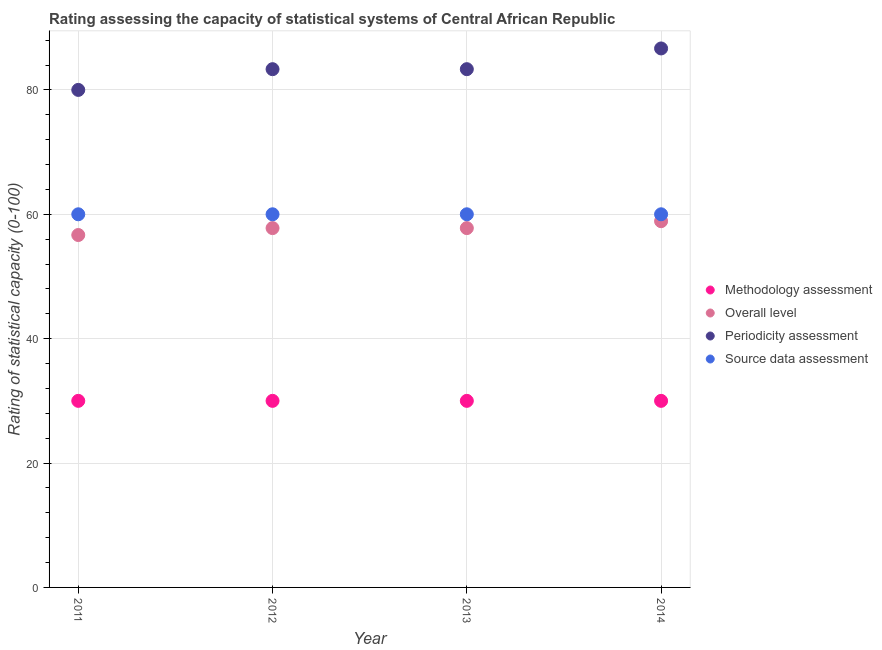How many different coloured dotlines are there?
Give a very brief answer. 4. Is the number of dotlines equal to the number of legend labels?
Your answer should be very brief. Yes. What is the periodicity assessment rating in 2011?
Ensure brevity in your answer.  80. Across all years, what is the maximum periodicity assessment rating?
Ensure brevity in your answer.  86.67. Across all years, what is the minimum methodology assessment rating?
Keep it short and to the point. 30. In which year was the methodology assessment rating maximum?
Offer a very short reply. 2011. In which year was the overall level rating minimum?
Make the answer very short. 2011. What is the total methodology assessment rating in the graph?
Offer a terse response. 120. What is the difference between the periodicity assessment rating in 2011 and that in 2013?
Offer a terse response. -3.33. What is the difference between the source data assessment rating in 2011 and the periodicity assessment rating in 2014?
Give a very brief answer. -26.67. In the year 2012, what is the difference between the overall level rating and periodicity assessment rating?
Provide a short and direct response. -25.56. What is the ratio of the source data assessment rating in 2013 to that in 2014?
Make the answer very short. 1. Is the source data assessment rating in 2011 less than that in 2013?
Your response must be concise. No. Is the difference between the periodicity assessment rating in 2011 and 2014 greater than the difference between the methodology assessment rating in 2011 and 2014?
Your response must be concise. No. What is the difference between the highest and the second highest methodology assessment rating?
Give a very brief answer. 0. In how many years, is the methodology assessment rating greater than the average methodology assessment rating taken over all years?
Offer a very short reply. 0. Is the sum of the periodicity assessment rating in 2013 and 2014 greater than the maximum source data assessment rating across all years?
Keep it short and to the point. Yes. Is the overall level rating strictly less than the methodology assessment rating over the years?
Your answer should be compact. No. What is the difference between two consecutive major ticks on the Y-axis?
Your answer should be compact. 20. Does the graph contain any zero values?
Offer a very short reply. No. Where does the legend appear in the graph?
Provide a short and direct response. Center right. How many legend labels are there?
Provide a succinct answer. 4. How are the legend labels stacked?
Your response must be concise. Vertical. What is the title of the graph?
Offer a terse response. Rating assessing the capacity of statistical systems of Central African Republic. Does "Taxes on exports" appear as one of the legend labels in the graph?
Keep it short and to the point. No. What is the label or title of the X-axis?
Your answer should be very brief. Year. What is the label or title of the Y-axis?
Offer a terse response. Rating of statistical capacity (0-100). What is the Rating of statistical capacity (0-100) in Overall level in 2011?
Keep it short and to the point. 56.67. What is the Rating of statistical capacity (0-100) in Overall level in 2012?
Your answer should be very brief. 57.78. What is the Rating of statistical capacity (0-100) of Periodicity assessment in 2012?
Your response must be concise. 83.33. What is the Rating of statistical capacity (0-100) of Source data assessment in 2012?
Provide a succinct answer. 60. What is the Rating of statistical capacity (0-100) of Overall level in 2013?
Your answer should be very brief. 57.78. What is the Rating of statistical capacity (0-100) in Periodicity assessment in 2013?
Keep it short and to the point. 83.33. What is the Rating of statistical capacity (0-100) of Source data assessment in 2013?
Give a very brief answer. 60. What is the Rating of statistical capacity (0-100) in Methodology assessment in 2014?
Keep it short and to the point. 30. What is the Rating of statistical capacity (0-100) in Overall level in 2014?
Your response must be concise. 58.89. What is the Rating of statistical capacity (0-100) of Periodicity assessment in 2014?
Offer a terse response. 86.67. What is the Rating of statistical capacity (0-100) of Source data assessment in 2014?
Give a very brief answer. 60. Across all years, what is the maximum Rating of statistical capacity (0-100) of Methodology assessment?
Give a very brief answer. 30. Across all years, what is the maximum Rating of statistical capacity (0-100) of Overall level?
Keep it short and to the point. 58.89. Across all years, what is the maximum Rating of statistical capacity (0-100) in Periodicity assessment?
Provide a succinct answer. 86.67. Across all years, what is the maximum Rating of statistical capacity (0-100) in Source data assessment?
Your answer should be compact. 60. Across all years, what is the minimum Rating of statistical capacity (0-100) of Methodology assessment?
Your answer should be compact. 30. Across all years, what is the minimum Rating of statistical capacity (0-100) of Overall level?
Your response must be concise. 56.67. Across all years, what is the minimum Rating of statistical capacity (0-100) in Periodicity assessment?
Your response must be concise. 80. Across all years, what is the minimum Rating of statistical capacity (0-100) of Source data assessment?
Ensure brevity in your answer.  60. What is the total Rating of statistical capacity (0-100) in Methodology assessment in the graph?
Offer a terse response. 120. What is the total Rating of statistical capacity (0-100) in Overall level in the graph?
Make the answer very short. 231.11. What is the total Rating of statistical capacity (0-100) of Periodicity assessment in the graph?
Your response must be concise. 333.33. What is the total Rating of statistical capacity (0-100) of Source data assessment in the graph?
Make the answer very short. 240. What is the difference between the Rating of statistical capacity (0-100) in Overall level in 2011 and that in 2012?
Ensure brevity in your answer.  -1.11. What is the difference between the Rating of statistical capacity (0-100) in Periodicity assessment in 2011 and that in 2012?
Provide a short and direct response. -3.33. What is the difference between the Rating of statistical capacity (0-100) in Overall level in 2011 and that in 2013?
Offer a very short reply. -1.11. What is the difference between the Rating of statistical capacity (0-100) of Source data assessment in 2011 and that in 2013?
Keep it short and to the point. 0. What is the difference between the Rating of statistical capacity (0-100) of Methodology assessment in 2011 and that in 2014?
Offer a terse response. 0. What is the difference between the Rating of statistical capacity (0-100) in Overall level in 2011 and that in 2014?
Make the answer very short. -2.22. What is the difference between the Rating of statistical capacity (0-100) of Periodicity assessment in 2011 and that in 2014?
Your answer should be compact. -6.67. What is the difference between the Rating of statistical capacity (0-100) in Source data assessment in 2011 and that in 2014?
Provide a short and direct response. 0. What is the difference between the Rating of statistical capacity (0-100) in Overall level in 2012 and that in 2013?
Make the answer very short. 0. What is the difference between the Rating of statistical capacity (0-100) in Source data assessment in 2012 and that in 2013?
Your answer should be very brief. 0. What is the difference between the Rating of statistical capacity (0-100) in Overall level in 2012 and that in 2014?
Offer a terse response. -1.11. What is the difference between the Rating of statistical capacity (0-100) in Periodicity assessment in 2012 and that in 2014?
Ensure brevity in your answer.  -3.33. What is the difference between the Rating of statistical capacity (0-100) in Overall level in 2013 and that in 2014?
Your answer should be compact. -1.11. What is the difference between the Rating of statistical capacity (0-100) in Periodicity assessment in 2013 and that in 2014?
Your answer should be very brief. -3.33. What is the difference between the Rating of statistical capacity (0-100) of Source data assessment in 2013 and that in 2014?
Offer a terse response. 0. What is the difference between the Rating of statistical capacity (0-100) in Methodology assessment in 2011 and the Rating of statistical capacity (0-100) in Overall level in 2012?
Your response must be concise. -27.78. What is the difference between the Rating of statistical capacity (0-100) of Methodology assessment in 2011 and the Rating of statistical capacity (0-100) of Periodicity assessment in 2012?
Your answer should be compact. -53.33. What is the difference between the Rating of statistical capacity (0-100) of Methodology assessment in 2011 and the Rating of statistical capacity (0-100) of Source data assessment in 2012?
Keep it short and to the point. -30. What is the difference between the Rating of statistical capacity (0-100) in Overall level in 2011 and the Rating of statistical capacity (0-100) in Periodicity assessment in 2012?
Provide a short and direct response. -26.67. What is the difference between the Rating of statistical capacity (0-100) in Overall level in 2011 and the Rating of statistical capacity (0-100) in Source data assessment in 2012?
Give a very brief answer. -3.33. What is the difference between the Rating of statistical capacity (0-100) of Methodology assessment in 2011 and the Rating of statistical capacity (0-100) of Overall level in 2013?
Your response must be concise. -27.78. What is the difference between the Rating of statistical capacity (0-100) of Methodology assessment in 2011 and the Rating of statistical capacity (0-100) of Periodicity assessment in 2013?
Your answer should be compact. -53.33. What is the difference between the Rating of statistical capacity (0-100) of Methodology assessment in 2011 and the Rating of statistical capacity (0-100) of Source data assessment in 2013?
Keep it short and to the point. -30. What is the difference between the Rating of statistical capacity (0-100) of Overall level in 2011 and the Rating of statistical capacity (0-100) of Periodicity assessment in 2013?
Your answer should be very brief. -26.67. What is the difference between the Rating of statistical capacity (0-100) in Overall level in 2011 and the Rating of statistical capacity (0-100) in Source data assessment in 2013?
Make the answer very short. -3.33. What is the difference between the Rating of statistical capacity (0-100) of Periodicity assessment in 2011 and the Rating of statistical capacity (0-100) of Source data assessment in 2013?
Provide a succinct answer. 20. What is the difference between the Rating of statistical capacity (0-100) of Methodology assessment in 2011 and the Rating of statistical capacity (0-100) of Overall level in 2014?
Ensure brevity in your answer.  -28.89. What is the difference between the Rating of statistical capacity (0-100) of Methodology assessment in 2011 and the Rating of statistical capacity (0-100) of Periodicity assessment in 2014?
Give a very brief answer. -56.67. What is the difference between the Rating of statistical capacity (0-100) in Methodology assessment in 2011 and the Rating of statistical capacity (0-100) in Source data assessment in 2014?
Your response must be concise. -30. What is the difference between the Rating of statistical capacity (0-100) in Overall level in 2011 and the Rating of statistical capacity (0-100) in Periodicity assessment in 2014?
Your response must be concise. -30. What is the difference between the Rating of statistical capacity (0-100) of Methodology assessment in 2012 and the Rating of statistical capacity (0-100) of Overall level in 2013?
Provide a succinct answer. -27.78. What is the difference between the Rating of statistical capacity (0-100) in Methodology assessment in 2012 and the Rating of statistical capacity (0-100) in Periodicity assessment in 2013?
Ensure brevity in your answer.  -53.33. What is the difference between the Rating of statistical capacity (0-100) in Overall level in 2012 and the Rating of statistical capacity (0-100) in Periodicity assessment in 2013?
Provide a succinct answer. -25.56. What is the difference between the Rating of statistical capacity (0-100) in Overall level in 2012 and the Rating of statistical capacity (0-100) in Source data assessment in 2013?
Your response must be concise. -2.22. What is the difference between the Rating of statistical capacity (0-100) of Periodicity assessment in 2012 and the Rating of statistical capacity (0-100) of Source data assessment in 2013?
Your answer should be compact. 23.33. What is the difference between the Rating of statistical capacity (0-100) in Methodology assessment in 2012 and the Rating of statistical capacity (0-100) in Overall level in 2014?
Your answer should be compact. -28.89. What is the difference between the Rating of statistical capacity (0-100) in Methodology assessment in 2012 and the Rating of statistical capacity (0-100) in Periodicity assessment in 2014?
Keep it short and to the point. -56.67. What is the difference between the Rating of statistical capacity (0-100) in Methodology assessment in 2012 and the Rating of statistical capacity (0-100) in Source data assessment in 2014?
Provide a short and direct response. -30. What is the difference between the Rating of statistical capacity (0-100) of Overall level in 2012 and the Rating of statistical capacity (0-100) of Periodicity assessment in 2014?
Provide a short and direct response. -28.89. What is the difference between the Rating of statistical capacity (0-100) in Overall level in 2012 and the Rating of statistical capacity (0-100) in Source data assessment in 2014?
Keep it short and to the point. -2.22. What is the difference between the Rating of statistical capacity (0-100) in Periodicity assessment in 2012 and the Rating of statistical capacity (0-100) in Source data assessment in 2014?
Keep it short and to the point. 23.33. What is the difference between the Rating of statistical capacity (0-100) in Methodology assessment in 2013 and the Rating of statistical capacity (0-100) in Overall level in 2014?
Your response must be concise. -28.89. What is the difference between the Rating of statistical capacity (0-100) in Methodology assessment in 2013 and the Rating of statistical capacity (0-100) in Periodicity assessment in 2014?
Offer a very short reply. -56.67. What is the difference between the Rating of statistical capacity (0-100) of Methodology assessment in 2013 and the Rating of statistical capacity (0-100) of Source data assessment in 2014?
Your answer should be compact. -30. What is the difference between the Rating of statistical capacity (0-100) of Overall level in 2013 and the Rating of statistical capacity (0-100) of Periodicity assessment in 2014?
Offer a very short reply. -28.89. What is the difference between the Rating of statistical capacity (0-100) in Overall level in 2013 and the Rating of statistical capacity (0-100) in Source data assessment in 2014?
Ensure brevity in your answer.  -2.22. What is the difference between the Rating of statistical capacity (0-100) in Periodicity assessment in 2013 and the Rating of statistical capacity (0-100) in Source data assessment in 2014?
Offer a terse response. 23.33. What is the average Rating of statistical capacity (0-100) of Methodology assessment per year?
Offer a very short reply. 30. What is the average Rating of statistical capacity (0-100) of Overall level per year?
Your answer should be very brief. 57.78. What is the average Rating of statistical capacity (0-100) in Periodicity assessment per year?
Offer a terse response. 83.33. What is the average Rating of statistical capacity (0-100) of Source data assessment per year?
Ensure brevity in your answer.  60. In the year 2011, what is the difference between the Rating of statistical capacity (0-100) of Methodology assessment and Rating of statistical capacity (0-100) of Overall level?
Provide a short and direct response. -26.67. In the year 2011, what is the difference between the Rating of statistical capacity (0-100) of Overall level and Rating of statistical capacity (0-100) of Periodicity assessment?
Your response must be concise. -23.33. In the year 2011, what is the difference between the Rating of statistical capacity (0-100) of Overall level and Rating of statistical capacity (0-100) of Source data assessment?
Your response must be concise. -3.33. In the year 2012, what is the difference between the Rating of statistical capacity (0-100) of Methodology assessment and Rating of statistical capacity (0-100) of Overall level?
Your response must be concise. -27.78. In the year 2012, what is the difference between the Rating of statistical capacity (0-100) of Methodology assessment and Rating of statistical capacity (0-100) of Periodicity assessment?
Your answer should be very brief. -53.33. In the year 2012, what is the difference between the Rating of statistical capacity (0-100) in Methodology assessment and Rating of statistical capacity (0-100) in Source data assessment?
Offer a very short reply. -30. In the year 2012, what is the difference between the Rating of statistical capacity (0-100) in Overall level and Rating of statistical capacity (0-100) in Periodicity assessment?
Offer a very short reply. -25.56. In the year 2012, what is the difference between the Rating of statistical capacity (0-100) of Overall level and Rating of statistical capacity (0-100) of Source data assessment?
Keep it short and to the point. -2.22. In the year 2012, what is the difference between the Rating of statistical capacity (0-100) in Periodicity assessment and Rating of statistical capacity (0-100) in Source data assessment?
Keep it short and to the point. 23.33. In the year 2013, what is the difference between the Rating of statistical capacity (0-100) in Methodology assessment and Rating of statistical capacity (0-100) in Overall level?
Make the answer very short. -27.78. In the year 2013, what is the difference between the Rating of statistical capacity (0-100) of Methodology assessment and Rating of statistical capacity (0-100) of Periodicity assessment?
Keep it short and to the point. -53.33. In the year 2013, what is the difference between the Rating of statistical capacity (0-100) in Overall level and Rating of statistical capacity (0-100) in Periodicity assessment?
Make the answer very short. -25.56. In the year 2013, what is the difference between the Rating of statistical capacity (0-100) in Overall level and Rating of statistical capacity (0-100) in Source data assessment?
Ensure brevity in your answer.  -2.22. In the year 2013, what is the difference between the Rating of statistical capacity (0-100) of Periodicity assessment and Rating of statistical capacity (0-100) of Source data assessment?
Give a very brief answer. 23.33. In the year 2014, what is the difference between the Rating of statistical capacity (0-100) of Methodology assessment and Rating of statistical capacity (0-100) of Overall level?
Offer a terse response. -28.89. In the year 2014, what is the difference between the Rating of statistical capacity (0-100) of Methodology assessment and Rating of statistical capacity (0-100) of Periodicity assessment?
Offer a terse response. -56.67. In the year 2014, what is the difference between the Rating of statistical capacity (0-100) of Overall level and Rating of statistical capacity (0-100) of Periodicity assessment?
Ensure brevity in your answer.  -27.78. In the year 2014, what is the difference between the Rating of statistical capacity (0-100) of Overall level and Rating of statistical capacity (0-100) of Source data assessment?
Ensure brevity in your answer.  -1.11. In the year 2014, what is the difference between the Rating of statistical capacity (0-100) of Periodicity assessment and Rating of statistical capacity (0-100) of Source data assessment?
Provide a short and direct response. 26.67. What is the ratio of the Rating of statistical capacity (0-100) in Methodology assessment in 2011 to that in 2012?
Your answer should be very brief. 1. What is the ratio of the Rating of statistical capacity (0-100) in Overall level in 2011 to that in 2012?
Provide a succinct answer. 0.98. What is the ratio of the Rating of statistical capacity (0-100) in Methodology assessment in 2011 to that in 2013?
Keep it short and to the point. 1. What is the ratio of the Rating of statistical capacity (0-100) in Overall level in 2011 to that in 2013?
Your answer should be very brief. 0.98. What is the ratio of the Rating of statistical capacity (0-100) in Methodology assessment in 2011 to that in 2014?
Offer a terse response. 1. What is the ratio of the Rating of statistical capacity (0-100) of Overall level in 2011 to that in 2014?
Ensure brevity in your answer.  0.96. What is the ratio of the Rating of statistical capacity (0-100) in Periodicity assessment in 2011 to that in 2014?
Offer a very short reply. 0.92. What is the ratio of the Rating of statistical capacity (0-100) of Source data assessment in 2011 to that in 2014?
Keep it short and to the point. 1. What is the ratio of the Rating of statistical capacity (0-100) in Source data assessment in 2012 to that in 2013?
Offer a very short reply. 1. What is the ratio of the Rating of statistical capacity (0-100) of Overall level in 2012 to that in 2014?
Ensure brevity in your answer.  0.98. What is the ratio of the Rating of statistical capacity (0-100) in Periodicity assessment in 2012 to that in 2014?
Ensure brevity in your answer.  0.96. What is the ratio of the Rating of statistical capacity (0-100) in Methodology assessment in 2013 to that in 2014?
Provide a short and direct response. 1. What is the ratio of the Rating of statistical capacity (0-100) in Overall level in 2013 to that in 2014?
Give a very brief answer. 0.98. What is the ratio of the Rating of statistical capacity (0-100) in Periodicity assessment in 2013 to that in 2014?
Make the answer very short. 0.96. What is the ratio of the Rating of statistical capacity (0-100) of Source data assessment in 2013 to that in 2014?
Your answer should be compact. 1. What is the difference between the highest and the second highest Rating of statistical capacity (0-100) in Source data assessment?
Offer a very short reply. 0. What is the difference between the highest and the lowest Rating of statistical capacity (0-100) of Overall level?
Offer a terse response. 2.22. What is the difference between the highest and the lowest Rating of statistical capacity (0-100) of Periodicity assessment?
Your response must be concise. 6.67. What is the difference between the highest and the lowest Rating of statistical capacity (0-100) of Source data assessment?
Provide a short and direct response. 0. 